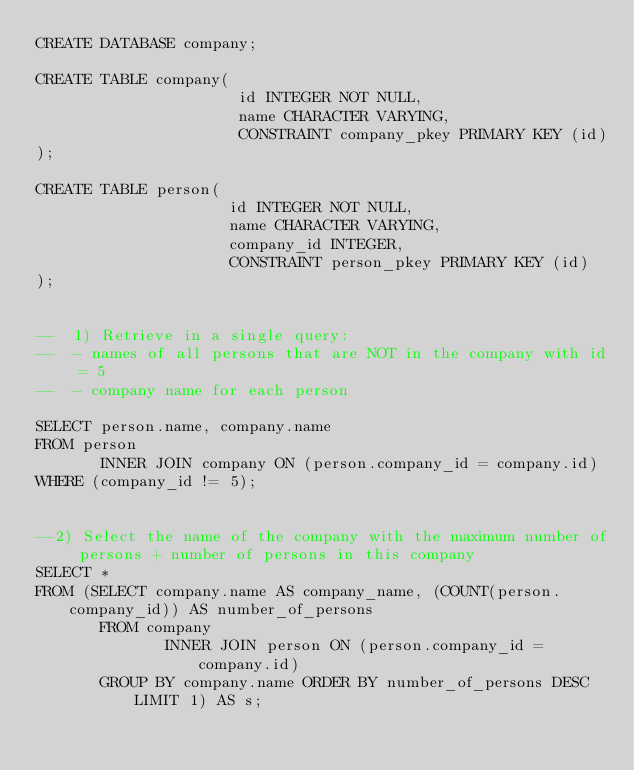<code> <loc_0><loc_0><loc_500><loc_500><_SQL_>CREATE DATABASE company;

CREATE TABLE company(
                      id INTEGER NOT NULL,
                      name CHARACTER VARYING,
                      CONSTRAINT company_pkey PRIMARY KEY (id)
);

CREATE TABLE person(
                     id INTEGER NOT NULL,
                     name CHARACTER VARYING,
                     company_id INTEGER,
                     CONSTRAINT person_pkey PRIMARY KEY (id)
);


--  1) Retrieve in a single query:
--  - names of all persons that are NOT in the company with id = 5
--  - company name for each person

SELECT person.name, company.name
FROM person
       INNER JOIN company ON (person.company_id = company.id)
WHERE (company_id != 5);


--2) Select the name of the company with the maximum number of persons + number of persons in this company
SELECT *
FROM (SELECT company.name AS company_name, (COUNT(person.company_id)) AS number_of_persons
       FROM company
              INNER JOIN person ON (person.company_id = company.id)
       GROUP BY company.name ORDER BY number_of_persons DESC LIMIT 1) AS s;
</code> 